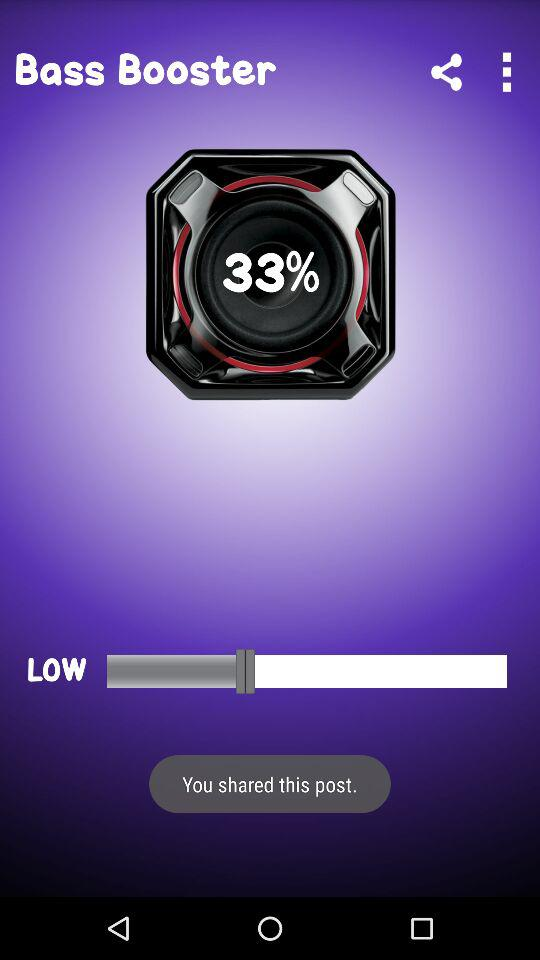What percentage is the speaker at?
Answer the question using a single word or phrase. 33% 